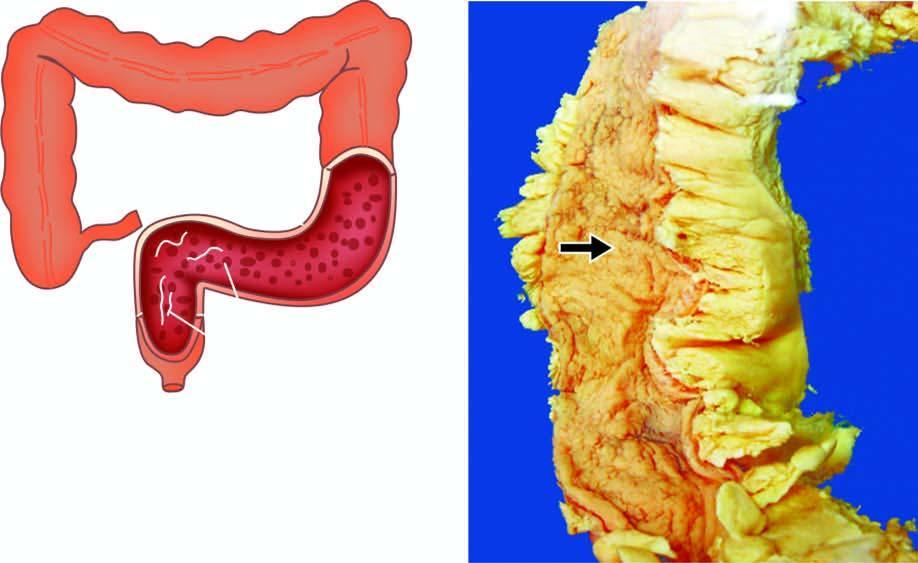what are superficial with intervening inflammatory pseudopolyps?
Answer the question using a single word or phrase. Ulcers 